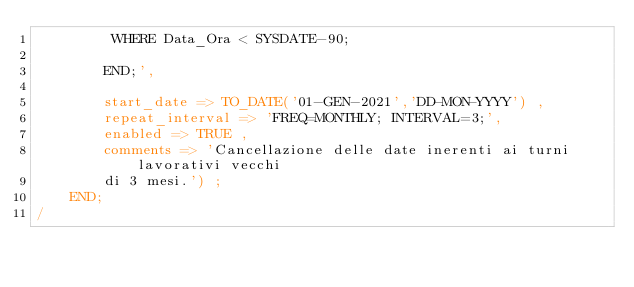<code> <loc_0><loc_0><loc_500><loc_500><_SQL_>		 WHERE Data_Ora < SYSDATE-90;
		
		END;',
		
		start_date => TO_DATE('01-GEN-2021','DD-MON-YYYY') ,
		repeat_interval => 'FREQ=MONTHLY; INTERVAL=3;',
		enabled => TRUE ,
		comments => 'Cancellazione delle date inerenti ai turni lavorativi vecchi 
		di 3 mesi.') ;
	END;
/</code> 